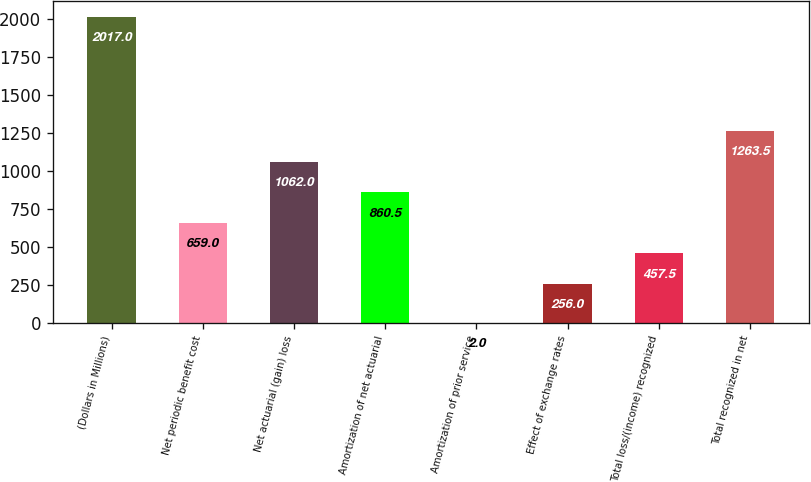Convert chart. <chart><loc_0><loc_0><loc_500><loc_500><bar_chart><fcel>(Dollars in Millions)<fcel>Net periodic benefit cost<fcel>Net actuarial (gain) loss<fcel>Amortization of net actuarial<fcel>Amortization of prior service<fcel>Effect of exchange rates<fcel>Total loss/(income) recognized<fcel>Total recognized in net<nl><fcel>2017<fcel>659<fcel>1062<fcel>860.5<fcel>2<fcel>256<fcel>457.5<fcel>1263.5<nl></chart> 